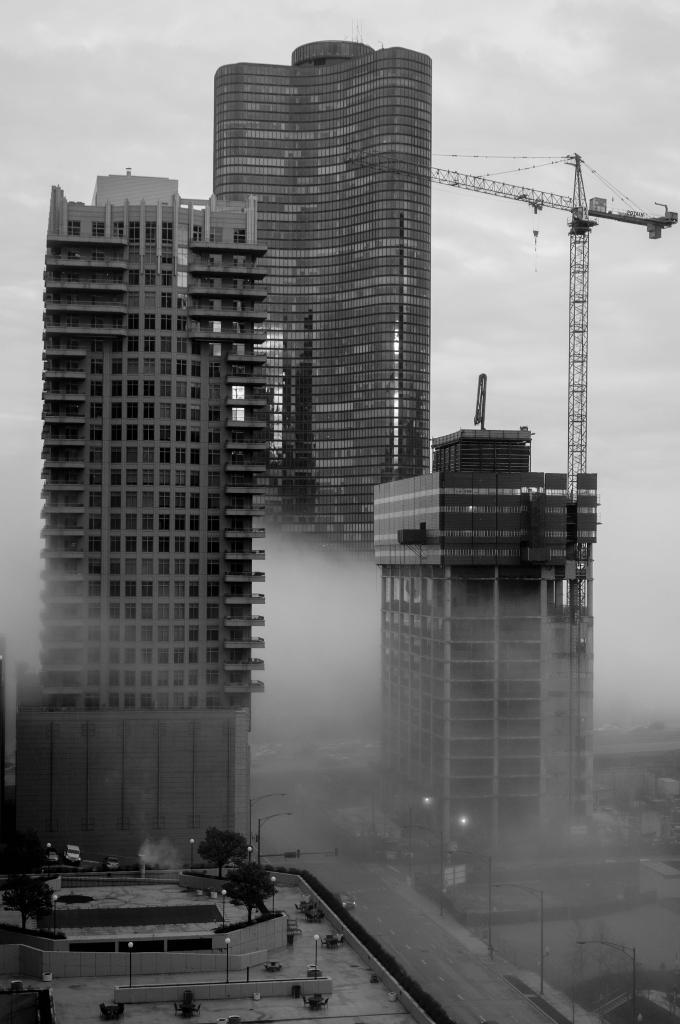What type of picture is in the image? The image contains a black and white picture. What structures can be seen in the picture? There are buildings in the image. What construction equipment is present in the image? There is a crane in the image. What type of lighting is present in the image? There are street lights in the image. What type of vegetation is present in the image? There are trees in the image. What type of transportation is present in the image? There is a vehicle on the road in the image. What part of the natural environment is visible in the image? The sky is visible in the background of the image. How many ants can be seen crawling on the crane in the image? There are no ants present in the image, so it is not possible to determine how many ants might be crawling on the crane. 